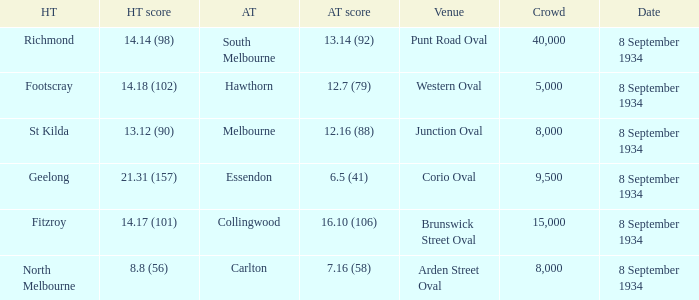When Melbourne was the Away team, what was their score? 12.16 (88). 